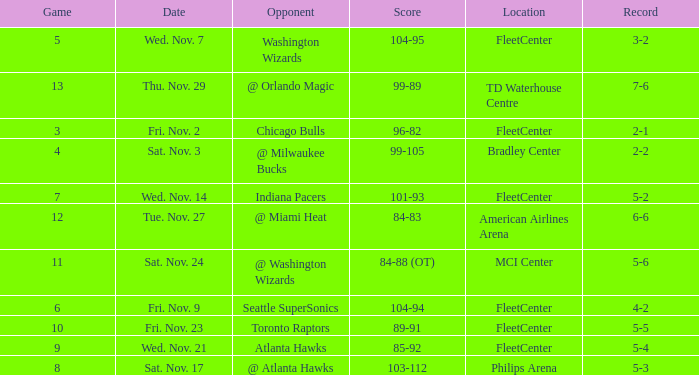What is the earliest game with a score of 99-89? 13.0. Could you parse the entire table as a dict? {'header': ['Game', 'Date', 'Opponent', 'Score', 'Location', 'Record'], 'rows': [['5', 'Wed. Nov. 7', 'Washington Wizards', '104-95', 'FleetCenter', '3-2'], ['13', 'Thu. Nov. 29', '@ Orlando Magic', '99-89', 'TD Waterhouse Centre', '7-6'], ['3', 'Fri. Nov. 2', 'Chicago Bulls', '96-82', 'FleetCenter', '2-1'], ['4', 'Sat. Nov. 3', '@ Milwaukee Bucks', '99-105', 'Bradley Center', '2-2'], ['7', 'Wed. Nov. 14', 'Indiana Pacers', '101-93', 'FleetCenter', '5-2'], ['12', 'Tue. Nov. 27', '@ Miami Heat', '84-83', 'American Airlines Arena', '6-6'], ['11', 'Sat. Nov. 24', '@ Washington Wizards', '84-88 (OT)', 'MCI Center', '5-6'], ['6', 'Fri. Nov. 9', 'Seattle SuperSonics', '104-94', 'FleetCenter', '4-2'], ['10', 'Fri. Nov. 23', 'Toronto Raptors', '89-91', 'FleetCenter', '5-5'], ['9', 'Wed. Nov. 21', 'Atlanta Hawks', '85-92', 'FleetCenter', '5-4'], ['8', 'Sat. Nov. 17', '@ Atlanta Hawks', '103-112', 'Philips Arena', '5-3']]} 